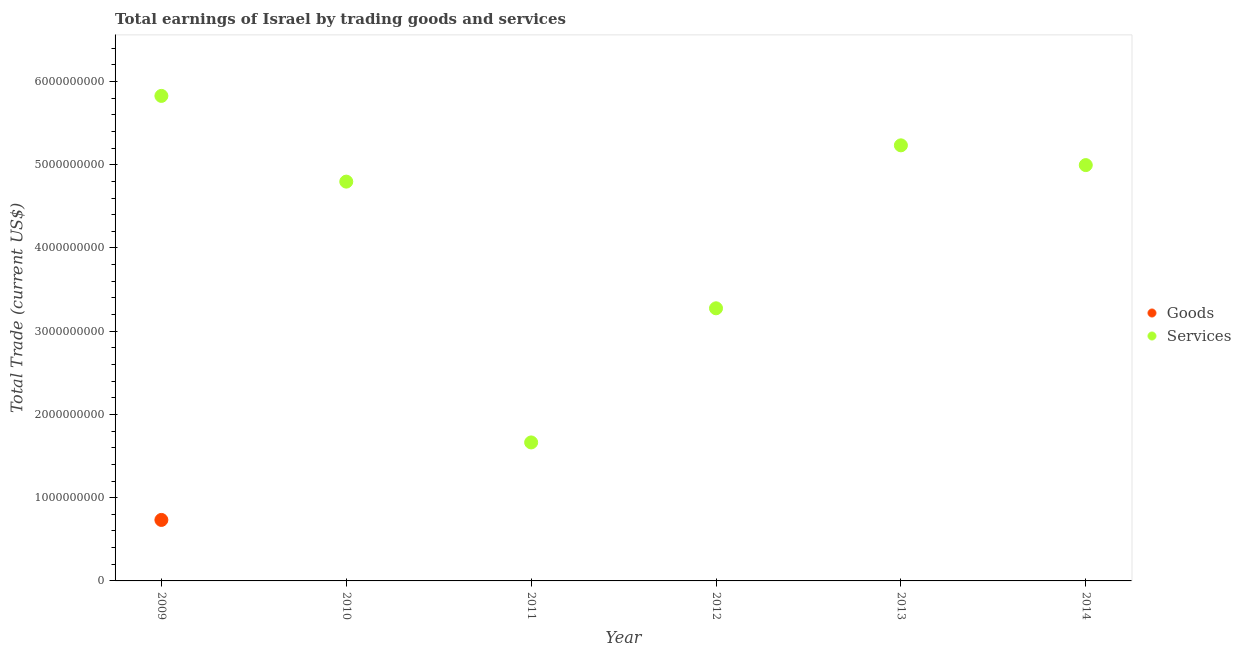Across all years, what is the maximum amount earned by trading services?
Offer a very short reply. 5.83e+09. In which year was the amount earned by trading goods maximum?
Provide a short and direct response. 2009. What is the total amount earned by trading goods in the graph?
Keep it short and to the point. 7.33e+08. What is the difference between the amount earned by trading services in 2009 and that in 2014?
Your response must be concise. 8.31e+08. What is the difference between the amount earned by trading goods in 2011 and the amount earned by trading services in 2014?
Give a very brief answer. -5.00e+09. What is the average amount earned by trading goods per year?
Ensure brevity in your answer.  1.22e+08. In the year 2009, what is the difference between the amount earned by trading services and amount earned by trading goods?
Offer a very short reply. 5.09e+09. What is the ratio of the amount earned by trading services in 2011 to that in 2012?
Ensure brevity in your answer.  0.51. Is the amount earned by trading services in 2011 less than that in 2012?
Your answer should be very brief. Yes. What is the difference between the highest and the second highest amount earned by trading services?
Make the answer very short. 5.94e+08. What is the difference between the highest and the lowest amount earned by trading services?
Make the answer very short. 4.16e+09. Is the sum of the amount earned by trading services in 2011 and 2013 greater than the maximum amount earned by trading goods across all years?
Provide a short and direct response. Yes. Does the amount earned by trading services monotonically increase over the years?
Keep it short and to the point. No. What is the difference between two consecutive major ticks on the Y-axis?
Offer a terse response. 1.00e+09. Does the graph contain grids?
Keep it short and to the point. No. Where does the legend appear in the graph?
Make the answer very short. Center right. How many legend labels are there?
Your answer should be very brief. 2. What is the title of the graph?
Keep it short and to the point. Total earnings of Israel by trading goods and services. What is the label or title of the X-axis?
Give a very brief answer. Year. What is the label or title of the Y-axis?
Your response must be concise. Total Trade (current US$). What is the Total Trade (current US$) in Goods in 2009?
Make the answer very short. 7.33e+08. What is the Total Trade (current US$) of Services in 2009?
Offer a very short reply. 5.83e+09. What is the Total Trade (current US$) of Services in 2010?
Your answer should be compact. 4.80e+09. What is the Total Trade (current US$) of Services in 2011?
Offer a terse response. 1.66e+09. What is the Total Trade (current US$) of Services in 2012?
Your answer should be compact. 3.28e+09. What is the Total Trade (current US$) in Services in 2013?
Offer a terse response. 5.23e+09. What is the Total Trade (current US$) of Services in 2014?
Your answer should be very brief. 5.00e+09. Across all years, what is the maximum Total Trade (current US$) of Goods?
Keep it short and to the point. 7.33e+08. Across all years, what is the maximum Total Trade (current US$) of Services?
Ensure brevity in your answer.  5.83e+09. Across all years, what is the minimum Total Trade (current US$) in Services?
Ensure brevity in your answer.  1.66e+09. What is the total Total Trade (current US$) of Goods in the graph?
Keep it short and to the point. 7.33e+08. What is the total Total Trade (current US$) of Services in the graph?
Keep it short and to the point. 2.58e+1. What is the difference between the Total Trade (current US$) of Services in 2009 and that in 2010?
Your response must be concise. 1.03e+09. What is the difference between the Total Trade (current US$) in Services in 2009 and that in 2011?
Your response must be concise. 4.16e+09. What is the difference between the Total Trade (current US$) of Services in 2009 and that in 2012?
Provide a short and direct response. 2.55e+09. What is the difference between the Total Trade (current US$) of Services in 2009 and that in 2013?
Offer a very short reply. 5.94e+08. What is the difference between the Total Trade (current US$) of Services in 2009 and that in 2014?
Offer a very short reply. 8.31e+08. What is the difference between the Total Trade (current US$) in Services in 2010 and that in 2011?
Your answer should be compact. 3.13e+09. What is the difference between the Total Trade (current US$) in Services in 2010 and that in 2012?
Offer a very short reply. 1.52e+09. What is the difference between the Total Trade (current US$) in Services in 2010 and that in 2013?
Your response must be concise. -4.36e+08. What is the difference between the Total Trade (current US$) of Services in 2010 and that in 2014?
Your answer should be very brief. -1.98e+08. What is the difference between the Total Trade (current US$) of Services in 2011 and that in 2012?
Your response must be concise. -1.61e+09. What is the difference between the Total Trade (current US$) in Services in 2011 and that in 2013?
Ensure brevity in your answer.  -3.57e+09. What is the difference between the Total Trade (current US$) in Services in 2011 and that in 2014?
Your answer should be very brief. -3.33e+09. What is the difference between the Total Trade (current US$) of Services in 2012 and that in 2013?
Give a very brief answer. -1.96e+09. What is the difference between the Total Trade (current US$) of Services in 2012 and that in 2014?
Ensure brevity in your answer.  -1.72e+09. What is the difference between the Total Trade (current US$) in Services in 2013 and that in 2014?
Provide a succinct answer. 2.37e+08. What is the difference between the Total Trade (current US$) of Goods in 2009 and the Total Trade (current US$) of Services in 2010?
Your response must be concise. -4.06e+09. What is the difference between the Total Trade (current US$) of Goods in 2009 and the Total Trade (current US$) of Services in 2011?
Your response must be concise. -9.31e+08. What is the difference between the Total Trade (current US$) in Goods in 2009 and the Total Trade (current US$) in Services in 2012?
Provide a short and direct response. -2.54e+09. What is the difference between the Total Trade (current US$) of Goods in 2009 and the Total Trade (current US$) of Services in 2013?
Your answer should be compact. -4.50e+09. What is the difference between the Total Trade (current US$) in Goods in 2009 and the Total Trade (current US$) in Services in 2014?
Make the answer very short. -4.26e+09. What is the average Total Trade (current US$) in Goods per year?
Make the answer very short. 1.22e+08. What is the average Total Trade (current US$) in Services per year?
Your answer should be very brief. 4.30e+09. In the year 2009, what is the difference between the Total Trade (current US$) in Goods and Total Trade (current US$) in Services?
Offer a terse response. -5.09e+09. What is the ratio of the Total Trade (current US$) in Services in 2009 to that in 2010?
Provide a short and direct response. 1.21. What is the ratio of the Total Trade (current US$) of Services in 2009 to that in 2011?
Your answer should be very brief. 3.5. What is the ratio of the Total Trade (current US$) in Services in 2009 to that in 2012?
Ensure brevity in your answer.  1.78. What is the ratio of the Total Trade (current US$) in Services in 2009 to that in 2013?
Keep it short and to the point. 1.11. What is the ratio of the Total Trade (current US$) in Services in 2009 to that in 2014?
Your response must be concise. 1.17. What is the ratio of the Total Trade (current US$) of Services in 2010 to that in 2011?
Provide a short and direct response. 2.88. What is the ratio of the Total Trade (current US$) in Services in 2010 to that in 2012?
Provide a short and direct response. 1.46. What is the ratio of the Total Trade (current US$) in Services in 2010 to that in 2013?
Provide a short and direct response. 0.92. What is the ratio of the Total Trade (current US$) in Services in 2010 to that in 2014?
Offer a very short reply. 0.96. What is the ratio of the Total Trade (current US$) in Services in 2011 to that in 2012?
Make the answer very short. 0.51. What is the ratio of the Total Trade (current US$) of Services in 2011 to that in 2013?
Offer a very short reply. 0.32. What is the ratio of the Total Trade (current US$) in Services in 2011 to that in 2014?
Offer a very short reply. 0.33. What is the ratio of the Total Trade (current US$) in Services in 2012 to that in 2013?
Your response must be concise. 0.63. What is the ratio of the Total Trade (current US$) of Services in 2012 to that in 2014?
Ensure brevity in your answer.  0.66. What is the ratio of the Total Trade (current US$) of Services in 2013 to that in 2014?
Provide a short and direct response. 1.05. What is the difference between the highest and the second highest Total Trade (current US$) in Services?
Provide a succinct answer. 5.94e+08. What is the difference between the highest and the lowest Total Trade (current US$) of Goods?
Ensure brevity in your answer.  7.33e+08. What is the difference between the highest and the lowest Total Trade (current US$) in Services?
Give a very brief answer. 4.16e+09. 